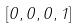<formula> <loc_0><loc_0><loc_500><loc_500>[ 0 , 0 , 0 , 1 ]</formula> 